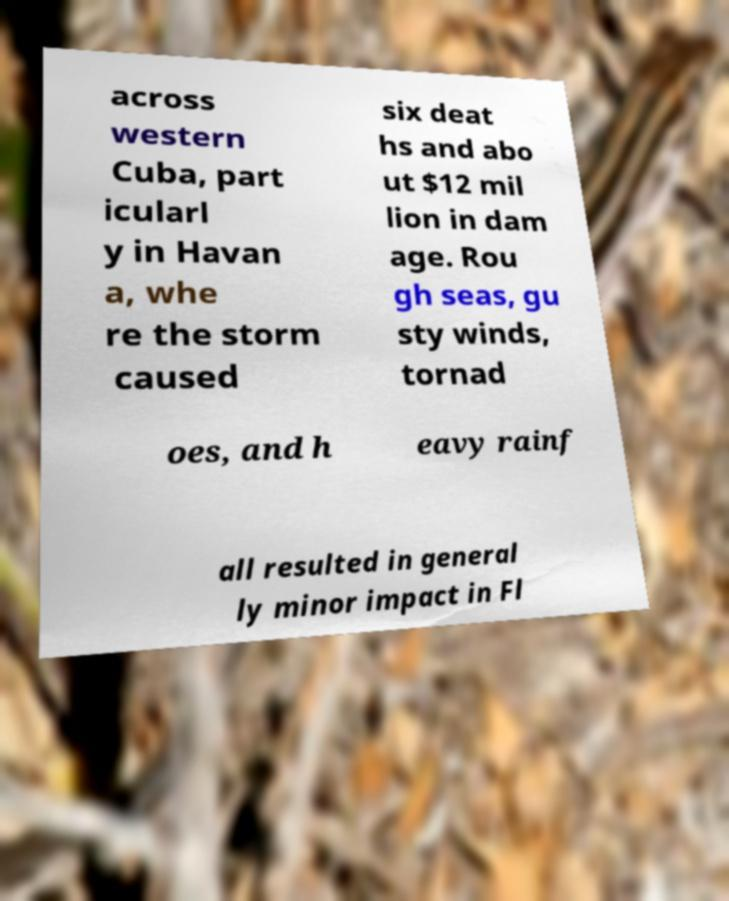Please identify and transcribe the text found in this image. across western Cuba, part icularl y in Havan a, whe re the storm caused six deat hs and abo ut $12 mil lion in dam age. Rou gh seas, gu sty winds, tornad oes, and h eavy rainf all resulted in general ly minor impact in Fl 